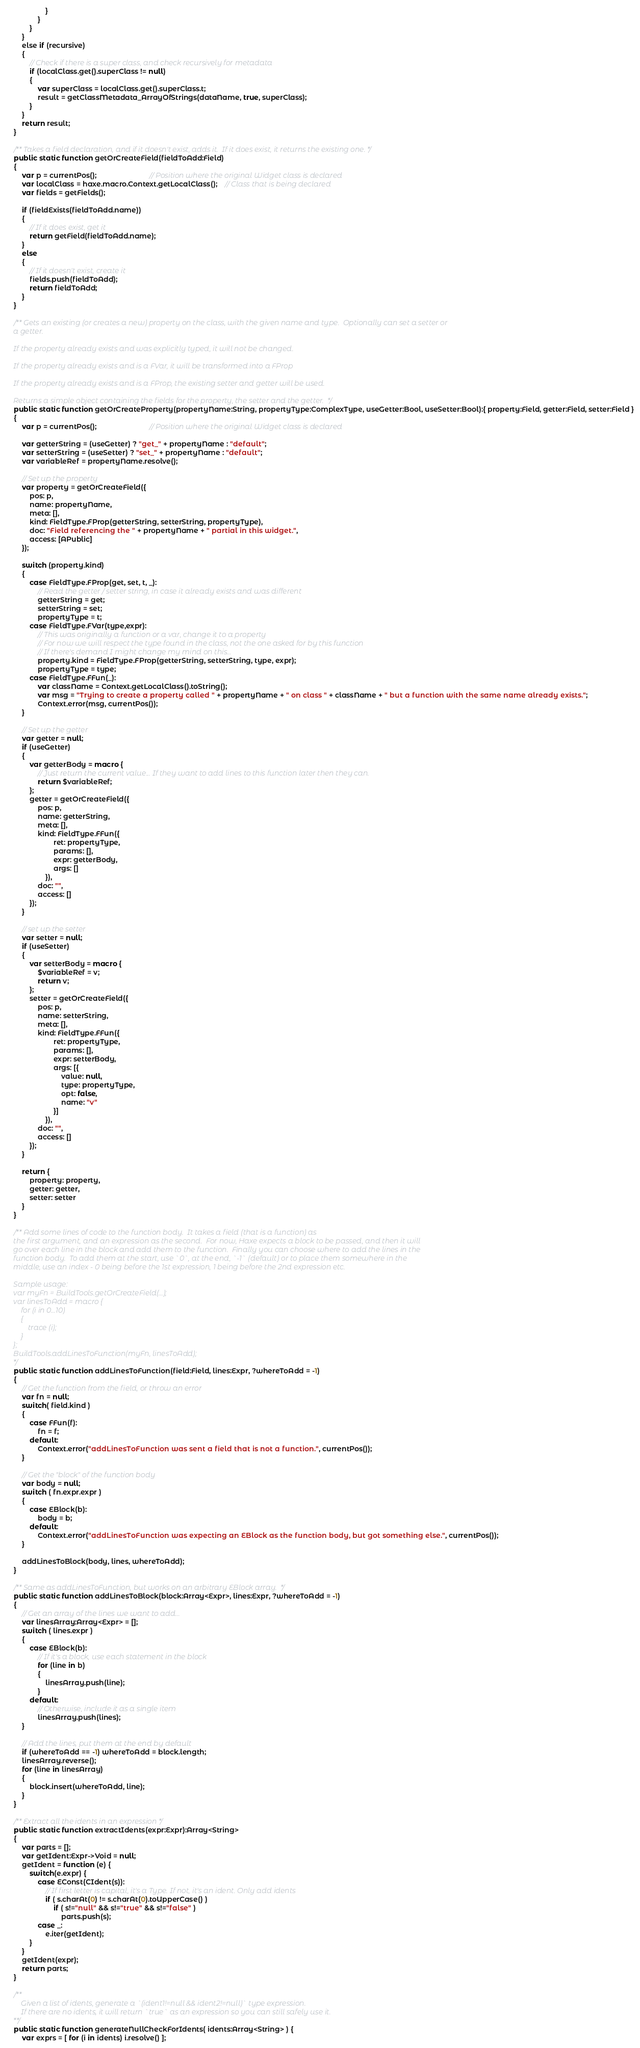Convert code to text. <code><loc_0><loc_0><loc_500><loc_500><_Haxe_>                    }
                }
            }
        }
        else if (recursive)
        {
            // Check if there is a super class, and check recursively for metadata
            if (localClass.get().superClass != null)
            {
                var superClass = localClass.get().superClass.t;
                result = getClassMetadata_ArrayOfStrings(dataName, true, superClass);
            }
        }
        return result;
    }

    /** Takes a field declaration, and if it doesn't exist, adds it.  If it does exist, it returns the existing one. */
    public static function getOrCreateField(fieldToAdd:Field)
    {
        var p = currentPos();                           // Position where the original Widget class is declared
        var localClass = haxe.macro.Context.getLocalClass();    // Class that is being declared
        var fields = getFields();

        if (fieldExists(fieldToAdd.name))
        {
            // If it does exist, get it
            return getField(fieldToAdd.name);
        }
        else
        {
            // If it doesn't exist, create it
            fields.push(fieldToAdd);
            return fieldToAdd;
        }
    }

    /** Gets an existing (or creates a new) property on the class, with the given name and type.  Optionally can set a setter or
    a getter.

    If the property already exists and was explicitly typed, it will not be changed.

    If the property already exists and is a FVar, it will be transformed into a FProp

    If the property already exists and is a FProp, the existing setter and getter will be used.

    Returns a simple object containing the fields for the property, the setter and the getter.  */
    public static function getOrCreateProperty(propertyName:String, propertyType:ComplexType, useGetter:Bool, useSetter:Bool):{ property:Field, getter:Field, setter:Field }
    {
        var p = currentPos();                           // Position where the original Widget class is declared

        var getterString = (useGetter) ? "get_" + propertyName : "default";
        var setterString = (useSetter) ? "set_" + propertyName : "default";
        var variableRef = propertyName.resolve();

        // Set up the property
        var property = getOrCreateField({
            pos: p,
            name: propertyName,
            meta: [],
            kind: FieldType.FProp(getterString, setterString, propertyType),
            doc: "Field referencing the " + propertyName + " partial in this widget.",
            access: [APublic]
        });

        switch (property.kind)
        {
            case FieldType.FProp(get, set, t, _):
                // Read the getter / setter string, in case it already exists and was different
                getterString = get;
                setterString = set;
                propertyType = t;
            case FieldType.FVar(type,expr):
                // This was originally a function or a var, change it to a property
                // For now we will respect the type found in the class, not the one asked for by this function
                // If there's demand I might change my mind on this...
                property.kind = FieldType.FProp(getterString, setterString, type, expr);
                propertyType = type;
            case FieldType.FFun(_):
                var className = Context.getLocalClass().toString();
                var msg = "Trying to create a property called " + propertyName + " on class " + className + " but a function with the same name already exists.";
                Context.error(msg, currentPos());
        }

        // Set up the getter
        var getter = null;
        if (useGetter)
        {
            var getterBody = macro {
                // Just return the current value... If they want to add lines to this function later then they can.
                return $variableRef;
            };
            getter = getOrCreateField({
                pos: p,
                name: getterString,
                meta: [],
                kind: FieldType.FFun({
                        ret: propertyType,
                        params: [],
                        expr: getterBody,
                        args: []
                    }),
                doc: "",
                access: []
            });
        }

        // set up the setter
        var setter = null;
        if (useSetter)
        {
            var setterBody = macro {
                $variableRef = v;
                return v;
            };
            setter = getOrCreateField({
                pos: p,
                name: setterString,
                meta: [],
                kind: FieldType.FFun({
                        ret: propertyType,
                        params: [],
                        expr: setterBody,
                        args: [{
                            value: null,
                            type: propertyType,
                            opt: false,
                            name: "v"
                        }]
                    }),
                doc: "",
                access: []
            });
        }

        return {
            property: property,
            getter: getter,
            setter: setter
        }
    }

    /** Add some lines of code to the function body.  It takes a field (that is a function) as
    the first argument, and an expression as the second.  For now, Haxe expects a block to be passed, and then it will
    go over each line in the block and add them to the function.  Finally you can choose where to add the lines in the
    function body.  To add them at the start, use `0`, at the end, `-1` (default) or to place them somewhere in the
    middle, use an index - 0 being before the 1st expression, 1 being before the 2nd expression etc.

    Sample usage:
    var myFn = BuildTools.getOrCreateField(...);
    var linesToAdd = macro {
        for (i in 0...10)
        {
            trace (i);
        }
    };
    BuildTools.addLinesToFunction(myFn, linesToAdd);
    */
    public static function addLinesToFunction(field:Field, lines:Expr, ?whereToAdd = -1)
    {
        // Get the function from the field, or throw an error
        var fn = null;
        switch( field.kind )
        {
            case FFun(f):
                fn = f;
            default:
                Context.error("addLinesToFunction was sent a field that is not a function.", currentPos());
        }

        // Get the "block" of the function body
        var body = null;
        switch ( fn.expr.expr )
        {
            case EBlock(b):
                body = b;
            default:
                Context.error("addLinesToFunction was expecting an EBlock as the function body, but got something else.", currentPos());
        }

        addLinesToBlock(body, lines, whereToAdd);
    }

    /** Same as addLinesToFunction, but works on an arbitrary EBlock array.  */
    public static function addLinesToBlock(block:Array<Expr>, lines:Expr, ?whereToAdd = -1)
    {
        // Get an array of the lines we want to add...
        var linesArray:Array<Expr> = [];
        switch ( lines.expr )
        {
            case EBlock(b):
                // If it's a block, use each statement in the block
                for (line in b)
                {
                    linesArray.push(line);
                }
            default:
                // Otherwise, include it as a single item
                linesArray.push(lines);
        }

        // Add the lines, put them at the end by default
        if (whereToAdd == -1) whereToAdd = block.length;
        linesArray.reverse();
        for (line in linesArray)
        {
            block.insert(whereToAdd, line);
        }
    }

    /** Extract all the idents in an expression */
    public static function extractIdents(expr:Expr):Array<String>
    {
        var parts = [];
        var getIdent:Expr->Void = null;
        getIdent = function (e) {
            switch(e.expr) {
                case EConst(CIdent(s)):
                    // If first letter is capital, it's a Type. If not, it's an ident. Only add idents
                    if ( s.charAt(0) != s.charAt(0).toUpperCase() )
                        if ( s!="null" && s!="true" && s!="false" )
                            parts.push(s);
                case _:
                    e.iter(getIdent);
            }
        }
        getIdent(expr);
        return parts;
    }

    /**
        Given a list of idents, generate a `(ident1!=null && ident2!=null)` type expression.
        If there are no idents, it will return `true` as an expression so you can still safely use it.
    **/
    public static function generateNullCheckForIdents( idents:Array<String> ) {
        var exprs = [ for (i in idents) i.resolve() ];</code> 